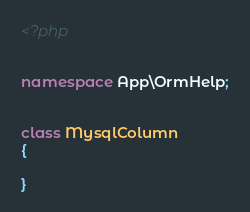<code> <loc_0><loc_0><loc_500><loc_500><_PHP_><?php


namespace App\OrmHelp;


class MysqlColumn
{

}</code> 